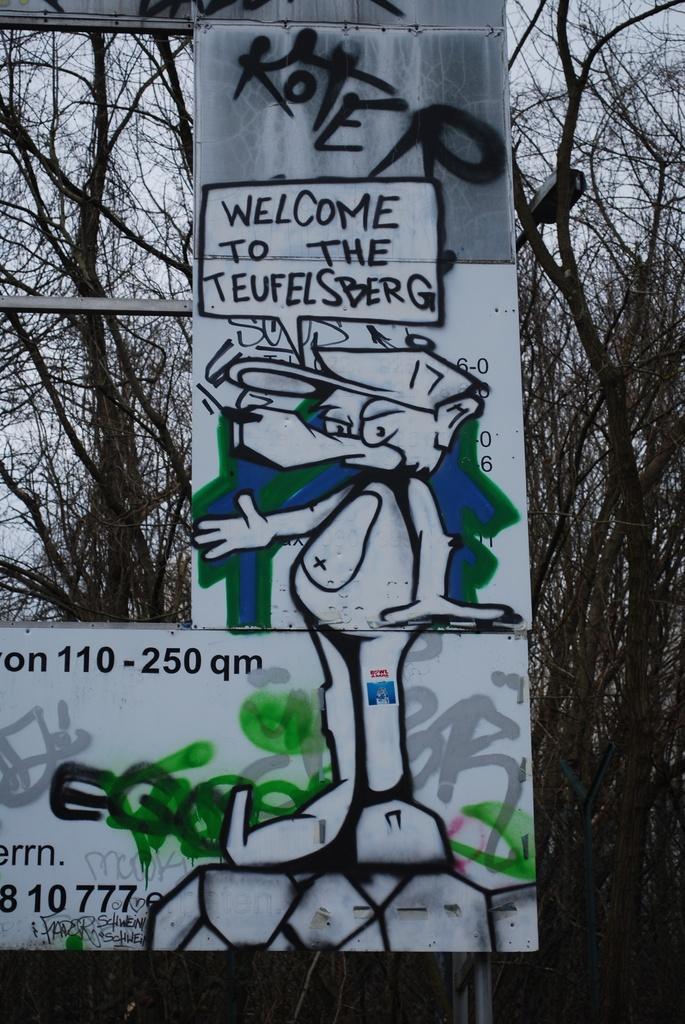In one or two sentences, can you explain what this image depicts? In this picture we can see boards and pole. In the background of the image we can see trees, light and sky. 